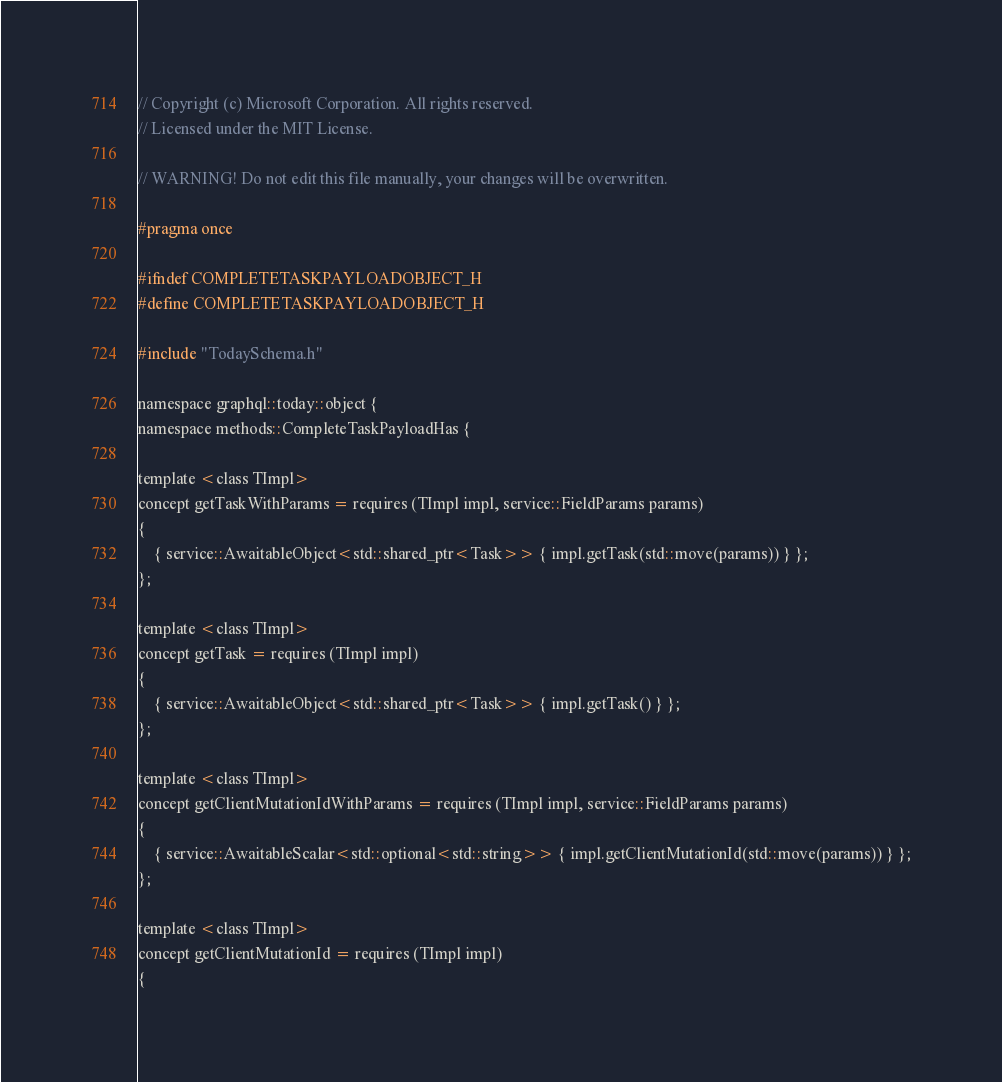Convert code to text. <code><loc_0><loc_0><loc_500><loc_500><_C_>// Copyright (c) Microsoft Corporation. All rights reserved.
// Licensed under the MIT License.

// WARNING! Do not edit this file manually, your changes will be overwritten.

#pragma once

#ifndef COMPLETETASKPAYLOADOBJECT_H
#define COMPLETETASKPAYLOADOBJECT_H

#include "TodaySchema.h"

namespace graphql::today::object {
namespace methods::CompleteTaskPayloadHas {

template <class TImpl>
concept getTaskWithParams = requires (TImpl impl, service::FieldParams params)
{
	{ service::AwaitableObject<std::shared_ptr<Task>> { impl.getTask(std::move(params)) } };
};

template <class TImpl>
concept getTask = requires (TImpl impl)
{
	{ service::AwaitableObject<std::shared_ptr<Task>> { impl.getTask() } };
};

template <class TImpl>
concept getClientMutationIdWithParams = requires (TImpl impl, service::FieldParams params)
{
	{ service::AwaitableScalar<std::optional<std::string>> { impl.getClientMutationId(std::move(params)) } };
};

template <class TImpl>
concept getClientMutationId = requires (TImpl impl)
{</code> 